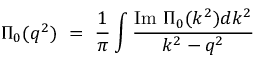<formula> <loc_0><loc_0><loc_500><loc_500>\Pi _ { 0 } ( q ^ { 2 } ) \ = \ \frac { 1 } { \pi } \int \frac { I m \Pi _ { 0 } ( k ^ { 2 } ) d k ^ { 2 } } { k ^ { 2 } - q ^ { 2 } }</formula> 